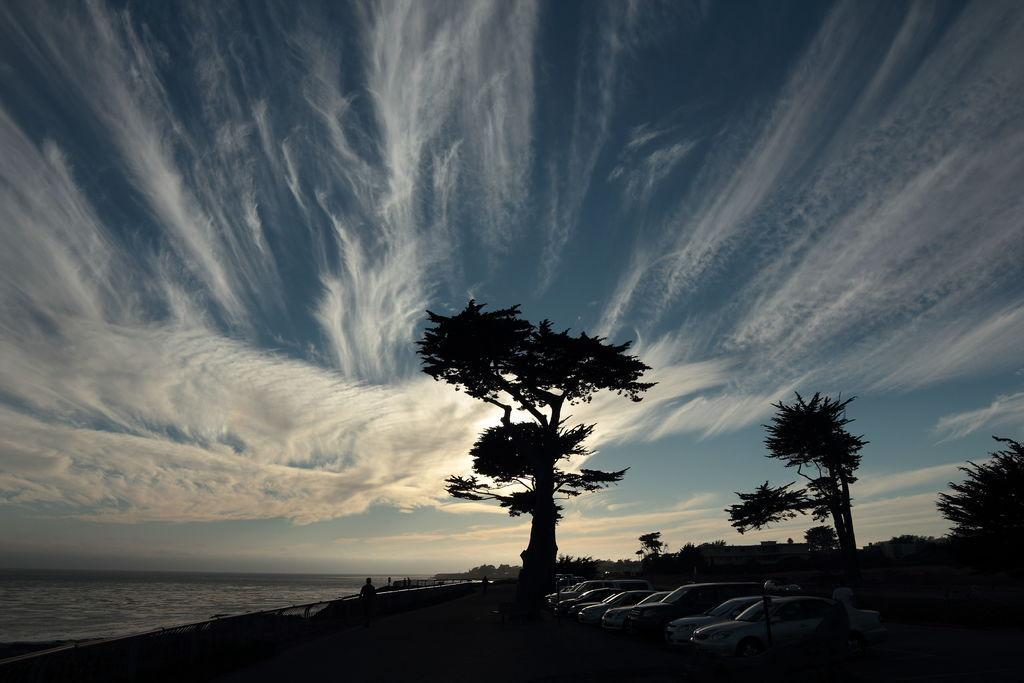Describe this image in one or two sentences. This is an outside view. On the left side there is an ocean. On the right side there are few cars on the ground and also I can see many trees. Here I can see few people in the dark. At the top of the image I can see the sky and clouds. 